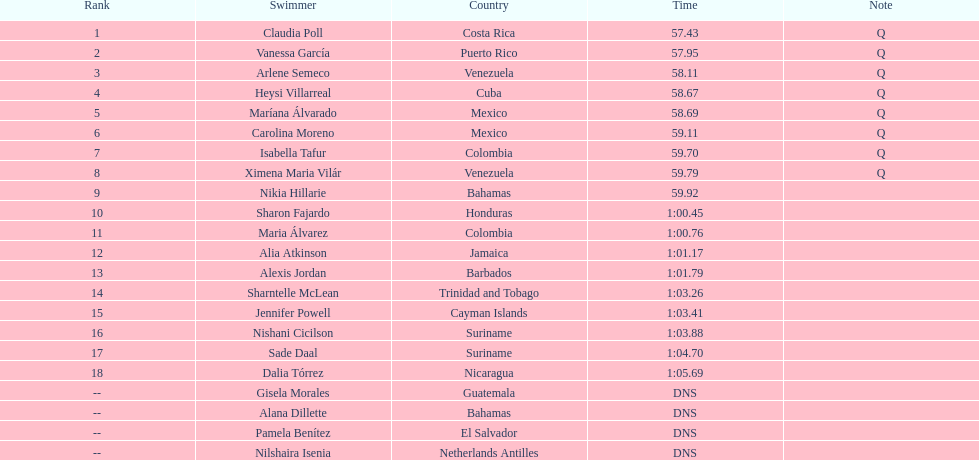How many competitors did not start the preliminaries? 4. 